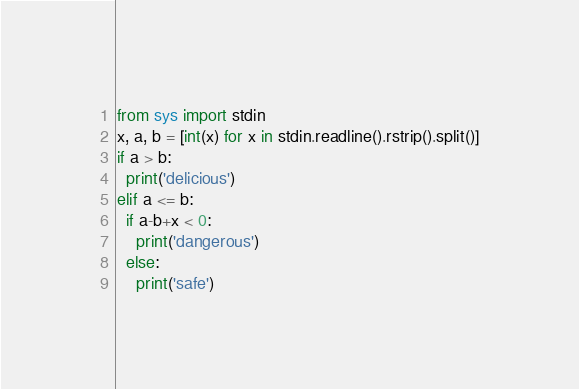Convert code to text. <code><loc_0><loc_0><loc_500><loc_500><_Python_>from sys import stdin
x, a, b = [int(x) for x in stdin.readline().rstrip().split()]
if a > b:
  print('delicious')
elif a <= b:
  if a-b+x < 0:
    print('dangerous')
  else:
    print('safe')</code> 